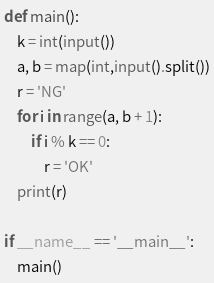Convert code to text. <code><loc_0><loc_0><loc_500><loc_500><_Python_>def main():
    k = int(input())
    a, b = map(int,input().split())
    r = 'NG'
    for i in range(a, b + 1):
        if i % k == 0:
            r = 'OK'
    print(r)

if __name__ == '__main__':
    main()</code> 